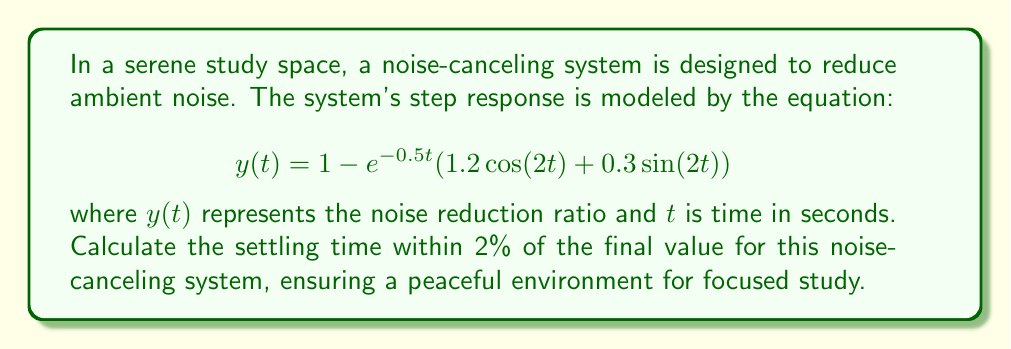Give your solution to this math problem. To find the settling time within 2% of the final value, we need to follow these steps:

1. Determine the final value of the system:
   As $t \to \infty$, $e^{-0.5t} \to 0$, so the final value is 1.

2. Calculate the error bounds:
   The system should settle within 2% of the final value, so the acceptable range is:
   $1 \pm 0.02 = [0.98, 1.02]$

3. Simplify the equation:
   Let $f(t) = e^{-0.5t}(1.2\cos(2t) + 0.3\sin(2t))$
   Then, $y(t) = 1 - f(t)$

4. Find when $|f(t)| \leq 0.02$:
   $|f(t)| = |e^{-0.5t}(1.2\cos(2t) + 0.3\sin(2t))|$
   $\leq e^{-0.5t}(1.2|\cos(2t)| + 0.3|\sin(2t)|)$
   $\leq e^{-0.5t}(1.2 + 0.3) = 1.5e^{-0.5t}$

5. Solve the inequality:
   $1.5e^{-0.5t} \leq 0.02$
   $e^{-0.5t} \leq \frac{0.02}{1.5} = \frac{1}{75}$
   $-0.5t \leq \ln(\frac{1}{75})$
   $t \geq -\frac{2}{0.5}\ln(\frac{1}{75}) = 8.63$ seconds

Therefore, the settling time within 2% of the final value is approximately 8.63 seconds.
Answer: The settling time within 2% of the final value for the noise-canceling system is approximately 8.63 seconds. 